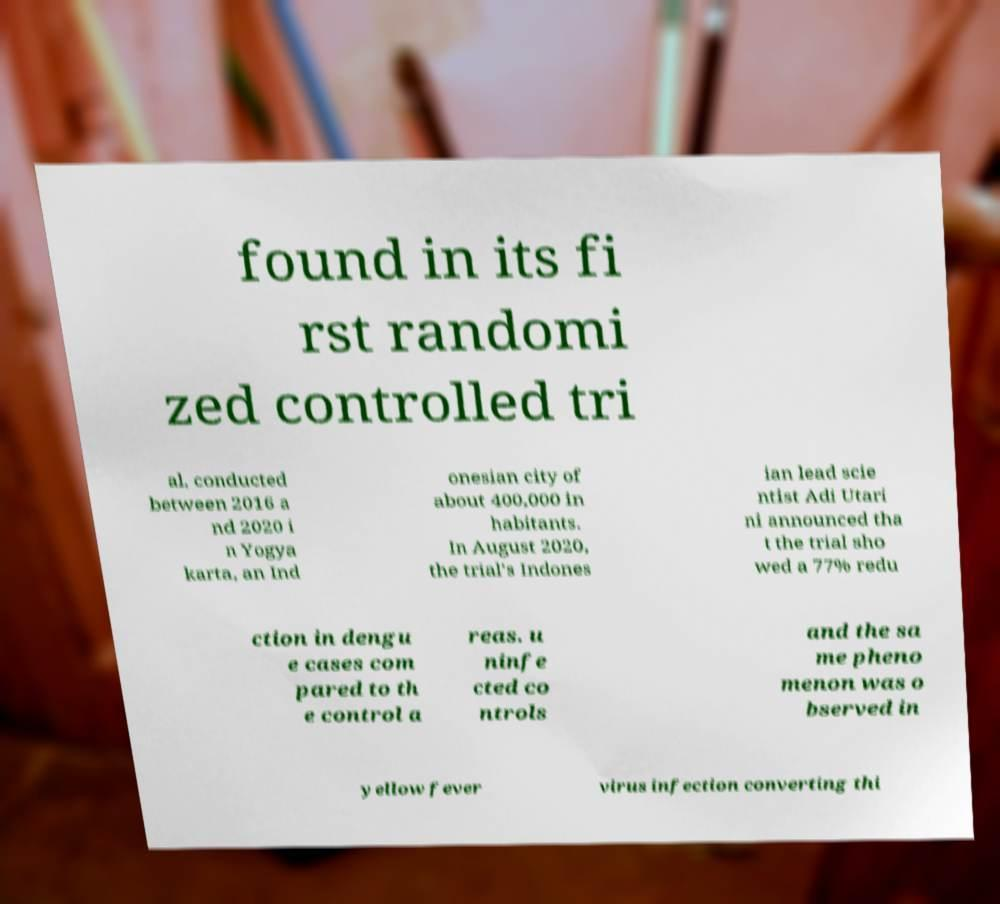Could you extract and type out the text from this image? found in its fi rst randomi zed controlled tri al, conducted between 2016 a nd 2020 i n Yogya karta, an Ind onesian city of about 400,000 in habitants. In August 2020, the trial's Indones ian lead scie ntist Adi Utari ni announced tha t the trial sho wed a 77% redu ction in dengu e cases com pared to th e control a reas. u ninfe cted co ntrols and the sa me pheno menon was o bserved in yellow fever virus infection converting thi 